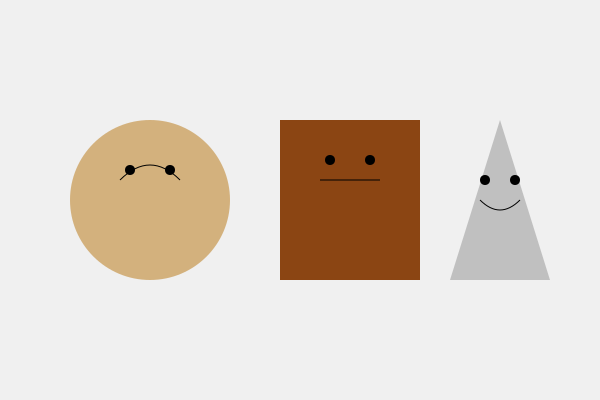Analyze the facial expressions and body language depicted in these three sculptures from different cultural backgrounds. Which sculpture appears to convey the most positive emotion, and what elements support this interpretation? To answer this question, we need to examine each sculpture's facial features and overall posture, considering cultural context:

1. Sculpture 1 (circular form):
   - Curved upward mouth, suggesting a smile
   - Round, soft features indicating warmth
   - Eyes positioned to appear open and engaged
   - Overall circular shape may represent unity or completeness

2. Sculpture 2 (rectangular form):
   - Straight line for mouth, suggesting a neutral expression
   - Angular features implying strength or stoicism
   - Eyes set high, potentially indicating alertness or wariness
   - Rigid rectangular shape may represent stability or inflexibility

3. Sculpture 3 (triangular form):
   - Curved upward mouth, suggesting a slight smile
   - Sharp, angular features implying intensity or focus
   - Eyes set wide apart, potentially indicating openness or vision
   - Triangular shape may represent aspiration or hierarchy

Comparing these elements:
- Sculpture 1 shows the most obvious positive emotion through its clear smile and soft, welcoming features.
- Sculpture 2 appears the most neutral or reserved.
- Sculpture 3 shows a slight positive emotion but with more intensity than warmth.

Cultural considerations:
- Circular forms often represent harmony in many African and Asian cultures.
- Rectangular shapes may symbolize strength and stability in various indigenous American art forms.
- Triangular forms can represent divinity or aspiration in numerous global traditions.

Given these analyses, Sculpture 1 appears to convey the most positive emotion, supported by its clear smile, soft features, and culturally resonant circular form suggesting harmony and completeness.
Answer: Sculpture 1, due to its clear smile, soft features, and harmonious circular form. 